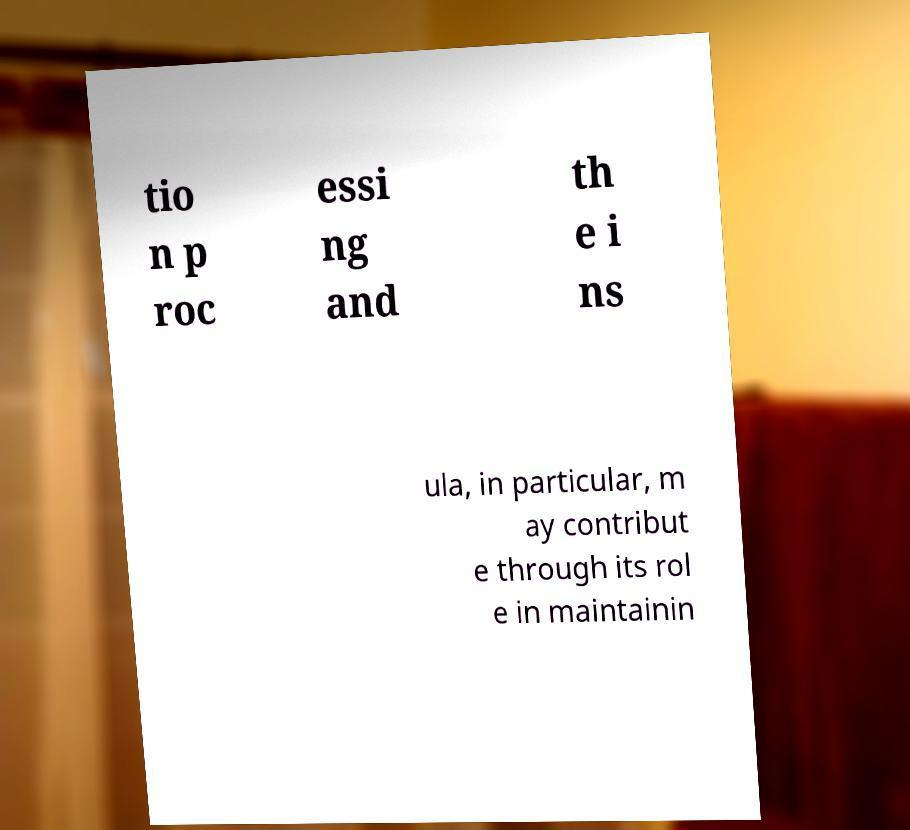Could you extract and type out the text from this image? tio n p roc essi ng and th e i ns ula, in particular, m ay contribut e through its rol e in maintainin 